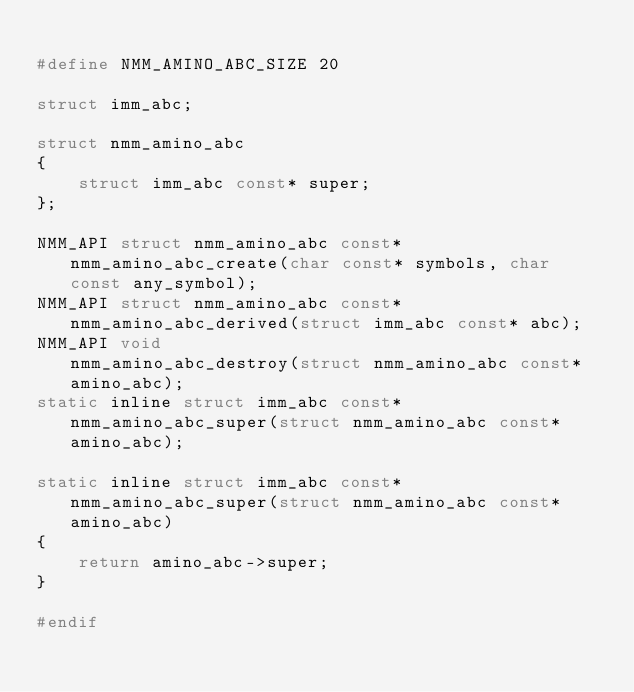<code> <loc_0><loc_0><loc_500><loc_500><_C_>
#define NMM_AMINO_ABC_SIZE 20

struct imm_abc;

struct nmm_amino_abc
{
    struct imm_abc const* super;
};

NMM_API struct nmm_amino_abc const* nmm_amino_abc_create(char const* symbols, char const any_symbol);
NMM_API struct nmm_amino_abc const* nmm_amino_abc_derived(struct imm_abc const* abc);
NMM_API void                        nmm_amino_abc_destroy(struct nmm_amino_abc const* amino_abc);
static inline struct imm_abc const* nmm_amino_abc_super(struct nmm_amino_abc const* amino_abc);

static inline struct imm_abc const* nmm_amino_abc_super(struct nmm_amino_abc const* amino_abc)
{
    return amino_abc->super;
}

#endif
</code> 